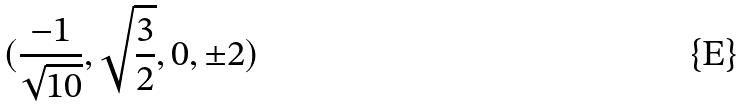Convert formula to latex. <formula><loc_0><loc_0><loc_500><loc_500>( \frac { - 1 } { \sqrt { 1 0 } } , \sqrt { \frac { 3 } { 2 } } , 0 , \pm 2 )</formula> 